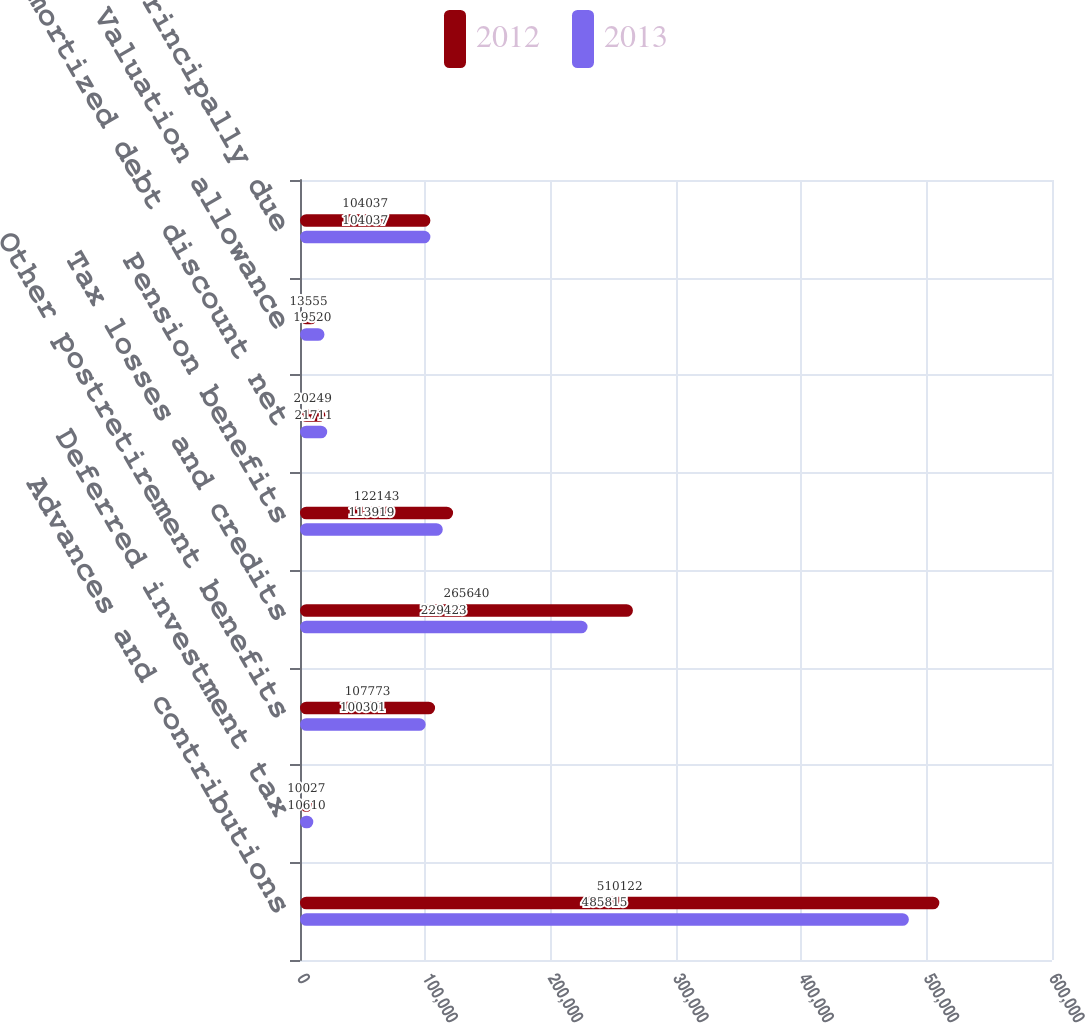Convert chart to OTSL. <chart><loc_0><loc_0><loc_500><loc_500><stacked_bar_chart><ecel><fcel>Advances and contributions<fcel>Deferred investment tax<fcel>Other postretirement benefits<fcel>Tax losses and credits<fcel>Pension benefits<fcel>Unamortized debt discount net<fcel>Valuation allowance<fcel>Utility plant principally due<nl><fcel>2012<fcel>510122<fcel>10027<fcel>107773<fcel>265640<fcel>122143<fcel>20249<fcel>13555<fcel>104037<nl><fcel>2013<fcel>485815<fcel>10610<fcel>100301<fcel>229423<fcel>113919<fcel>21711<fcel>19520<fcel>104037<nl></chart> 